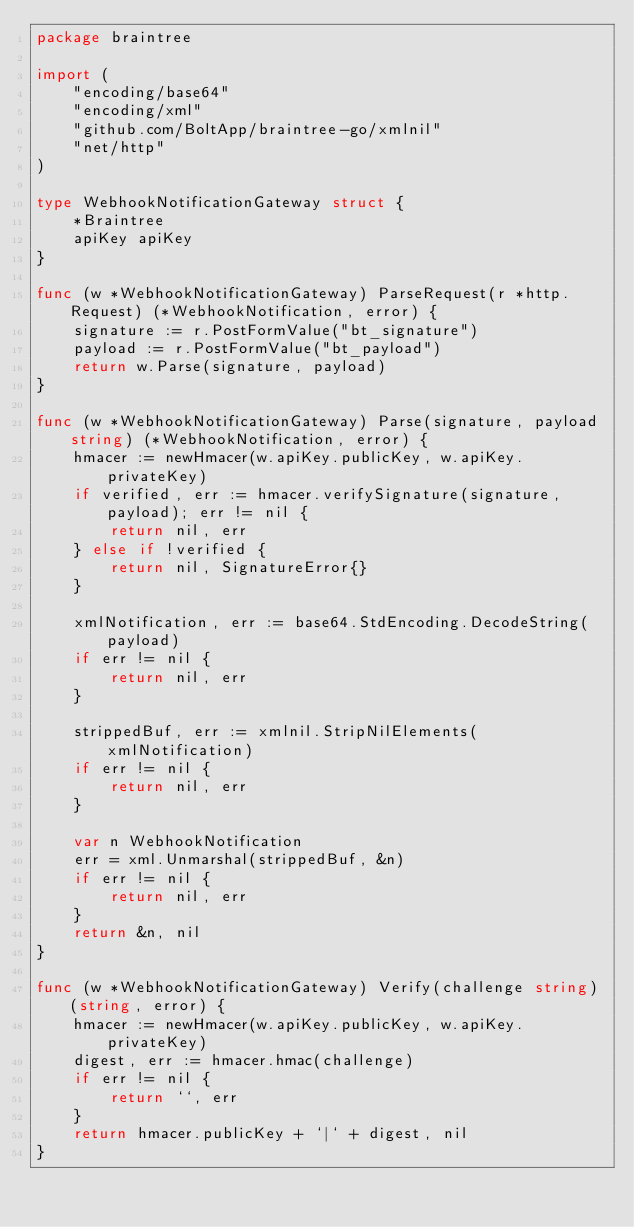Convert code to text. <code><loc_0><loc_0><loc_500><loc_500><_Go_>package braintree

import (
	"encoding/base64"
	"encoding/xml"
	"github.com/BoltApp/braintree-go/xmlnil"
	"net/http"
)

type WebhookNotificationGateway struct {
	*Braintree
	apiKey apiKey
}

func (w *WebhookNotificationGateway) ParseRequest(r *http.Request) (*WebhookNotification, error) {
	signature := r.PostFormValue("bt_signature")
	payload := r.PostFormValue("bt_payload")
	return w.Parse(signature, payload)
}

func (w *WebhookNotificationGateway) Parse(signature, payload string) (*WebhookNotification, error) {
	hmacer := newHmacer(w.apiKey.publicKey, w.apiKey.privateKey)
	if verified, err := hmacer.verifySignature(signature, payload); err != nil {
		return nil, err
	} else if !verified {
		return nil, SignatureError{}
	}

	xmlNotification, err := base64.StdEncoding.DecodeString(payload)
	if err != nil {
		return nil, err
	}

	strippedBuf, err := xmlnil.StripNilElements(xmlNotification)
	if err != nil {
		return nil, err
	}

	var n WebhookNotification
	err = xml.Unmarshal(strippedBuf, &n)
	if err != nil {
		return nil, err
	}
	return &n, nil
}

func (w *WebhookNotificationGateway) Verify(challenge string) (string, error) {
	hmacer := newHmacer(w.apiKey.publicKey, w.apiKey.privateKey)
	digest, err := hmacer.hmac(challenge)
	if err != nil {
		return ``, err
	}
	return hmacer.publicKey + `|` + digest, nil
}
</code> 